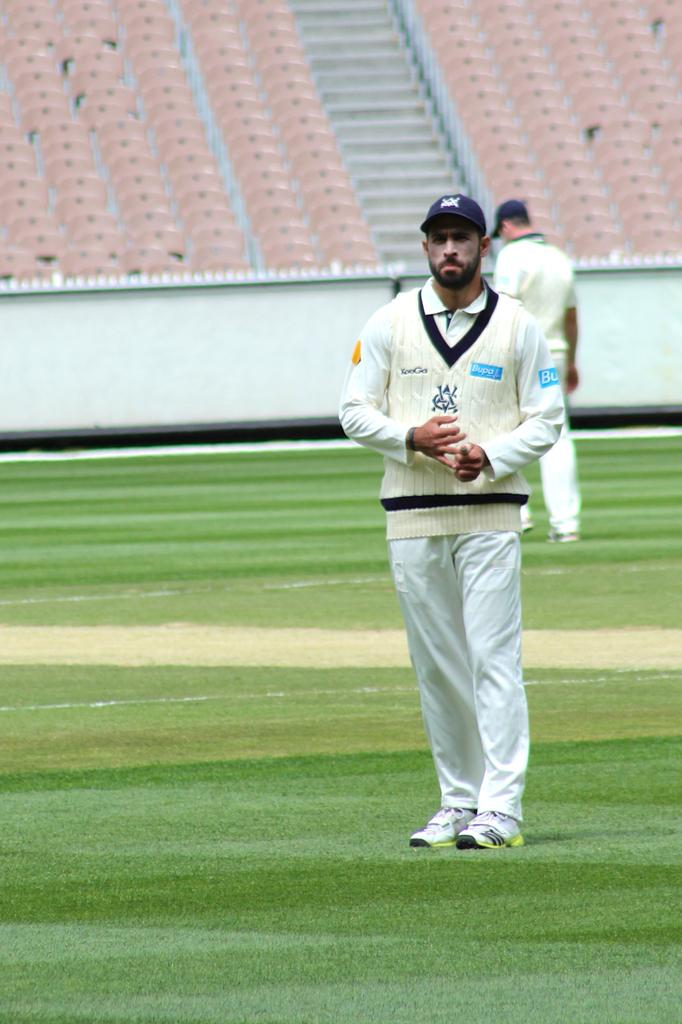<image>
Write a terse but informative summary of the picture. The light blue advertising on the mans shirt is for Bupa 